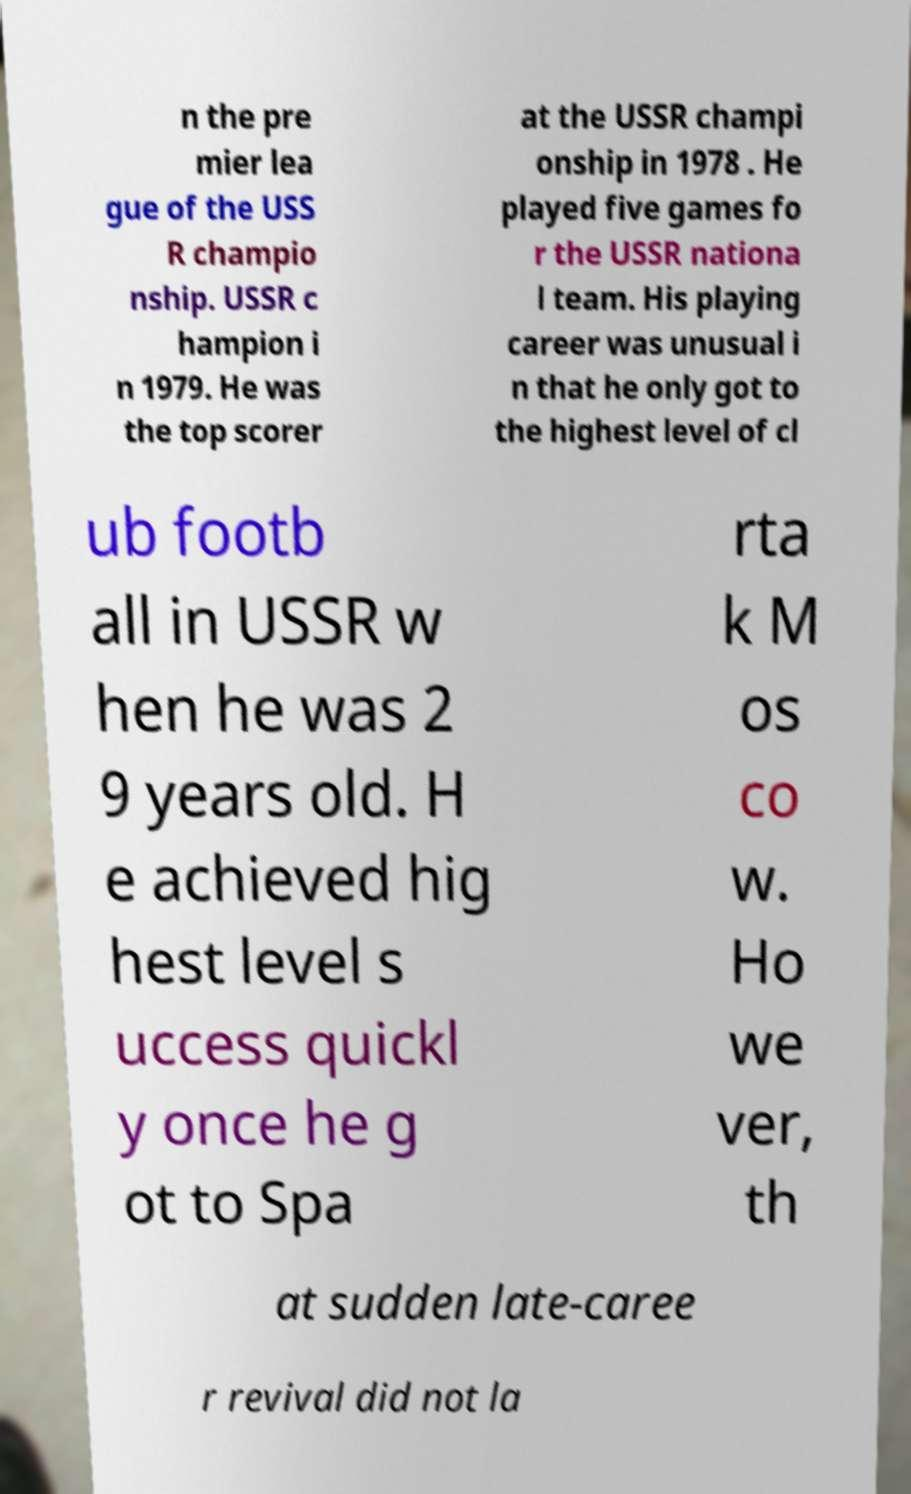What messages or text are displayed in this image? I need them in a readable, typed format. n the pre mier lea gue of the USS R champio nship. USSR c hampion i n 1979. He was the top scorer at the USSR champi onship in 1978 . He played five games fo r the USSR nationa l team. His playing career was unusual i n that he only got to the highest level of cl ub footb all in USSR w hen he was 2 9 years old. H e achieved hig hest level s uccess quickl y once he g ot to Spa rta k M os co w. Ho we ver, th at sudden late-caree r revival did not la 